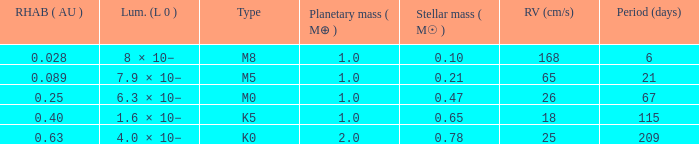What is the total stellar mass of the type m0? 0.47. 